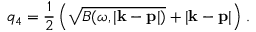Convert formula to latex. <formula><loc_0><loc_0><loc_500><loc_500>q _ { 4 } = { \frac { 1 } { 2 } } \left ( \sqrt { B ( \omega , | { k } - { p } | ) } + | { k } - { p } | \right ) \, .</formula> 